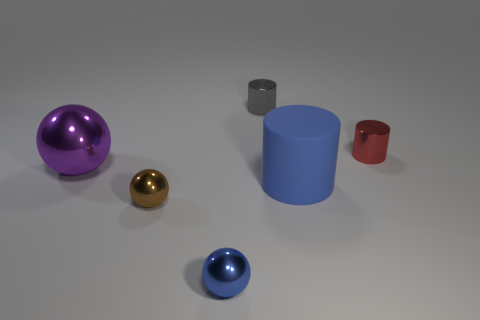What number of red rubber things are the same size as the purple shiny thing?
Your answer should be very brief. 0. Is the large thing right of the large purple sphere made of the same material as the cylinder that is behind the red cylinder?
Give a very brief answer. No. Is there any other thing that has the same shape as the gray shiny thing?
Offer a terse response. Yes. What color is the big sphere?
Your answer should be very brief. Purple. How many large blue objects are the same shape as the gray metallic thing?
Your answer should be very brief. 1. What is the color of the other sphere that is the same size as the blue shiny ball?
Provide a short and direct response. Brown. Are there any small metallic cylinders?
Offer a terse response. Yes. What is the shape of the blue object that is on the right side of the tiny blue shiny object?
Ensure brevity in your answer.  Cylinder. How many objects are both on the right side of the brown metal sphere and on the left side of the tiny red metallic object?
Your answer should be compact. 3. Are there any large green cylinders that have the same material as the large blue object?
Provide a short and direct response. No. 